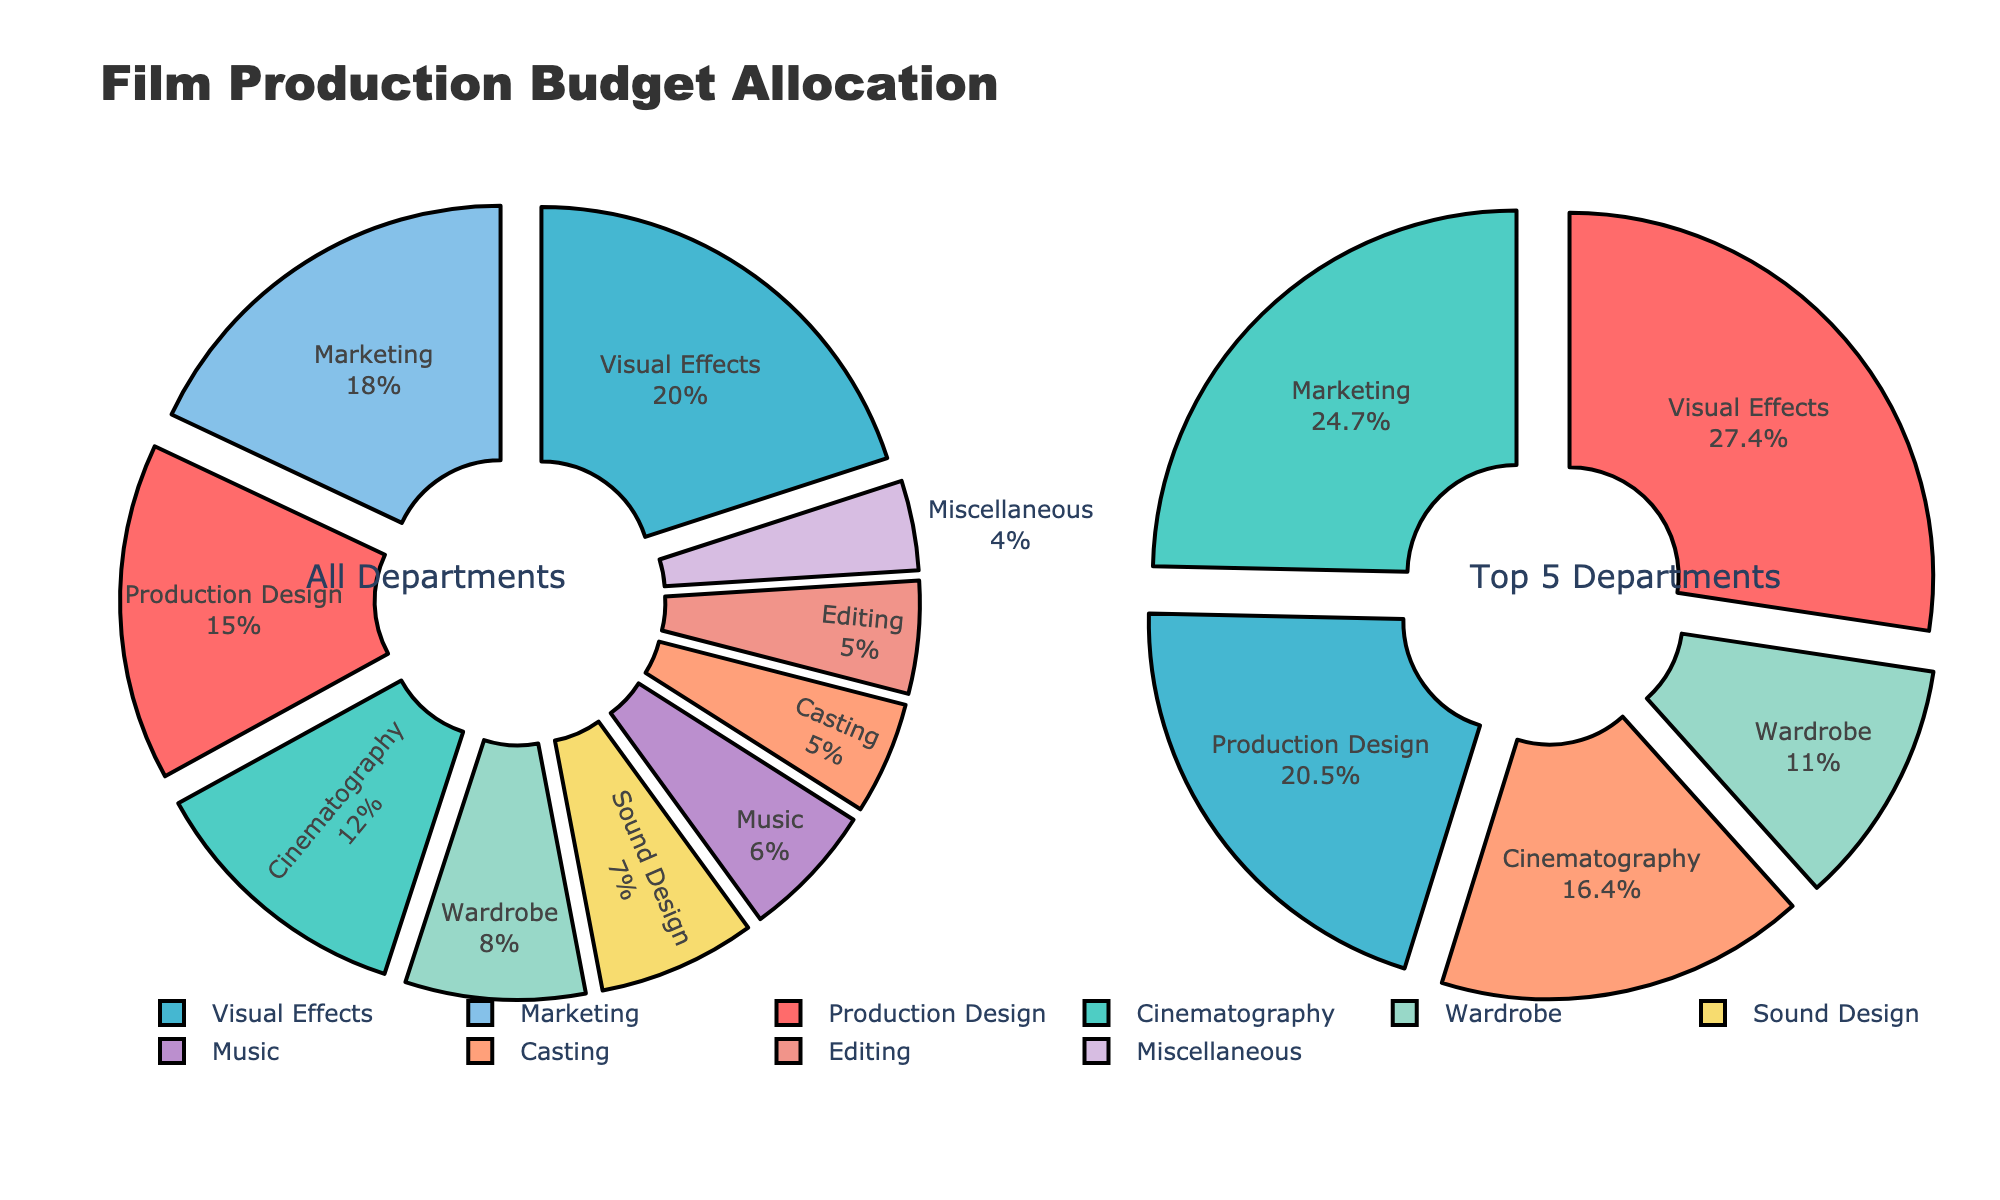What is the title of the figure? The title is located at the top of the figure. It provides a summary of what the figure is about. The text reads "Film Production Budget Allocation".
Answer: Film Production Budget Allocation Which department receives the highest budget percentage? By examining the 'Top 5 Departments' pie chart, we can see which segment occupies the largest space. The label for this segment reads "Visual Effects 20%".
Answer: Visual Effects How much budget percentage is allocated to the Marketing department? In the 'All Departments' pie chart, look for the segment labeled "Marketing". It shows that Marketing receives "18%" of the budget.
Answer: 18% Which departments are included in the 'Top 5 Departments' pie chart? Check the labels in the 'Top 5 Departments' pie chart. The segments correspond to "Visual Effects", "Marketing", "Production Design", "Cinematography", and "Wardrobe".
Answer: Visual Effects, Marketing, Production Design, Cinematography, Wardrobe What is the combined budget percentage for Editing and Casting? In the 'All Departments' chart, locate the labels for Editing and Casting. Their budget percentages are 5% each. Adding these up gives 5% + 5% = 10%.
Answer: 10% Which department has the smallest budget allocation, and what is its percentage? Within the 'All Departments' pie chart, identify the segment with the smallest size. The label "Miscellaneous" is the smallest, showing "4%".
Answer: Miscellaneous, 4% How does the budget allocation for Sound Design compare to that for Music? Examine the 'All Departments' pie chart for the segments labeled Sound Design and Music. Sound Design has 7% and Music has 6%. 7% is greater than 6%.
Answer: Sound Design has 1% more than Music What is the total budget allocation for the departments in the 'Top 5 Departments'? Sum the percentages from the 'Top 5 Departments' pie chart. They are: Visual Effects (20%), Marketing (18%), Production Design (15%), Cinematography (12%), Wardrobe (8%). Adding them gives 20% + 18% + 15% + 12% + 8% = 73%.
Answer: 73% Which color is used to represent the Production Design department? Identify the segment labeled "Production Design" in the 'All Departments' pie chart and note the color used to fill it. It is filled with a light red or pink color.
Answer: Light red or pink Is the combined budget for Sound Design and Music greater than that of Cinematography? Sum the budget percentages for Sound Design (7%) and Music (6%); this gives 13%. Compare this sum to Cinematography's percentage, which is 12%. Yes, 13% is greater than 12%.
Answer: Yes 